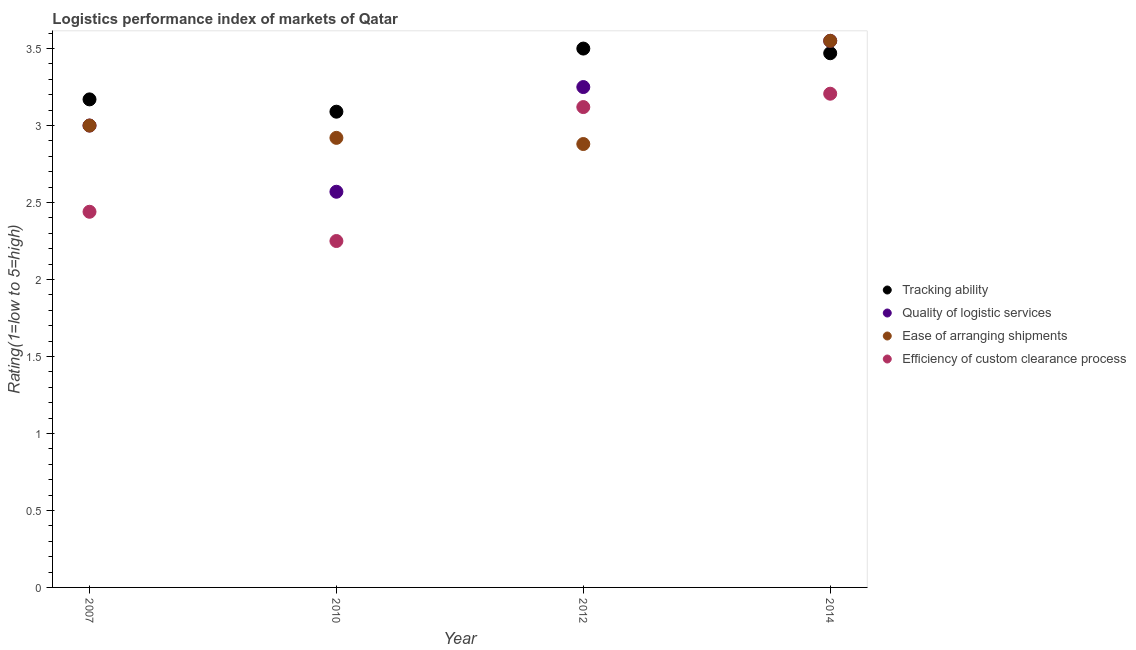How many different coloured dotlines are there?
Ensure brevity in your answer.  4. What is the lpi rating of quality of logistic services in 2014?
Your answer should be very brief. 3.55. Across all years, what is the maximum lpi rating of tracking ability?
Your answer should be very brief. 3.5. Across all years, what is the minimum lpi rating of quality of logistic services?
Your answer should be very brief. 2.57. In which year was the lpi rating of efficiency of custom clearance process maximum?
Keep it short and to the point. 2014. In which year was the lpi rating of quality of logistic services minimum?
Give a very brief answer. 2010. What is the total lpi rating of efficiency of custom clearance process in the graph?
Your answer should be compact. 11.02. What is the difference between the lpi rating of tracking ability in 2010 and that in 2014?
Offer a very short reply. -0.38. What is the difference between the lpi rating of ease of arranging shipments in 2007 and the lpi rating of quality of logistic services in 2012?
Make the answer very short. -0.25. What is the average lpi rating of efficiency of custom clearance process per year?
Give a very brief answer. 2.75. In the year 2010, what is the difference between the lpi rating of tracking ability and lpi rating of efficiency of custom clearance process?
Ensure brevity in your answer.  0.84. What is the ratio of the lpi rating of quality of logistic services in 2012 to that in 2014?
Keep it short and to the point. 0.92. Is the lpi rating of ease of arranging shipments in 2010 less than that in 2014?
Ensure brevity in your answer.  Yes. Is the difference between the lpi rating of tracking ability in 2010 and 2014 greater than the difference between the lpi rating of ease of arranging shipments in 2010 and 2014?
Your answer should be compact. Yes. What is the difference between the highest and the second highest lpi rating of efficiency of custom clearance process?
Provide a succinct answer. 0.09. What is the difference between the highest and the lowest lpi rating of efficiency of custom clearance process?
Your answer should be very brief. 0.96. Is the sum of the lpi rating of quality of logistic services in 2007 and 2010 greater than the maximum lpi rating of ease of arranging shipments across all years?
Your response must be concise. Yes. Is it the case that in every year, the sum of the lpi rating of quality of logistic services and lpi rating of ease of arranging shipments is greater than the sum of lpi rating of efficiency of custom clearance process and lpi rating of tracking ability?
Your response must be concise. No. Does the lpi rating of efficiency of custom clearance process monotonically increase over the years?
Ensure brevity in your answer.  No. How many dotlines are there?
Offer a terse response. 4. How many years are there in the graph?
Give a very brief answer. 4. What is the difference between two consecutive major ticks on the Y-axis?
Give a very brief answer. 0.5. Does the graph contain any zero values?
Ensure brevity in your answer.  No. Does the graph contain grids?
Your answer should be very brief. No. How many legend labels are there?
Make the answer very short. 4. How are the legend labels stacked?
Your answer should be compact. Vertical. What is the title of the graph?
Keep it short and to the point. Logistics performance index of markets of Qatar. What is the label or title of the Y-axis?
Your answer should be compact. Rating(1=low to 5=high). What is the Rating(1=low to 5=high) in Tracking ability in 2007?
Provide a short and direct response. 3.17. What is the Rating(1=low to 5=high) in Quality of logistic services in 2007?
Your answer should be very brief. 3. What is the Rating(1=low to 5=high) in Ease of arranging shipments in 2007?
Your response must be concise. 3. What is the Rating(1=low to 5=high) of Efficiency of custom clearance process in 2007?
Give a very brief answer. 2.44. What is the Rating(1=low to 5=high) of Tracking ability in 2010?
Keep it short and to the point. 3.09. What is the Rating(1=low to 5=high) of Quality of logistic services in 2010?
Provide a succinct answer. 2.57. What is the Rating(1=low to 5=high) of Ease of arranging shipments in 2010?
Make the answer very short. 2.92. What is the Rating(1=low to 5=high) of Efficiency of custom clearance process in 2010?
Keep it short and to the point. 2.25. What is the Rating(1=low to 5=high) of Ease of arranging shipments in 2012?
Your answer should be compact. 2.88. What is the Rating(1=low to 5=high) in Efficiency of custom clearance process in 2012?
Make the answer very short. 3.12. What is the Rating(1=low to 5=high) of Tracking ability in 2014?
Give a very brief answer. 3.47. What is the Rating(1=low to 5=high) in Quality of logistic services in 2014?
Your response must be concise. 3.55. What is the Rating(1=low to 5=high) of Ease of arranging shipments in 2014?
Your answer should be very brief. 3.55. What is the Rating(1=low to 5=high) of Efficiency of custom clearance process in 2014?
Your answer should be compact. 3.21. Across all years, what is the maximum Rating(1=low to 5=high) of Quality of logistic services?
Make the answer very short. 3.55. Across all years, what is the maximum Rating(1=low to 5=high) of Ease of arranging shipments?
Your answer should be very brief. 3.55. Across all years, what is the maximum Rating(1=low to 5=high) of Efficiency of custom clearance process?
Provide a short and direct response. 3.21. Across all years, what is the minimum Rating(1=low to 5=high) in Tracking ability?
Give a very brief answer. 3.09. Across all years, what is the minimum Rating(1=low to 5=high) in Quality of logistic services?
Your answer should be compact. 2.57. Across all years, what is the minimum Rating(1=low to 5=high) of Ease of arranging shipments?
Offer a very short reply. 2.88. Across all years, what is the minimum Rating(1=low to 5=high) in Efficiency of custom clearance process?
Your answer should be compact. 2.25. What is the total Rating(1=low to 5=high) of Tracking ability in the graph?
Provide a short and direct response. 13.23. What is the total Rating(1=low to 5=high) in Quality of logistic services in the graph?
Your response must be concise. 12.37. What is the total Rating(1=low to 5=high) in Ease of arranging shipments in the graph?
Provide a short and direct response. 12.35. What is the total Rating(1=low to 5=high) of Efficiency of custom clearance process in the graph?
Your response must be concise. 11.02. What is the difference between the Rating(1=low to 5=high) of Quality of logistic services in 2007 and that in 2010?
Your answer should be very brief. 0.43. What is the difference between the Rating(1=low to 5=high) of Efficiency of custom clearance process in 2007 and that in 2010?
Your response must be concise. 0.19. What is the difference between the Rating(1=low to 5=high) of Tracking ability in 2007 and that in 2012?
Ensure brevity in your answer.  -0.33. What is the difference between the Rating(1=low to 5=high) of Quality of logistic services in 2007 and that in 2012?
Provide a succinct answer. -0.25. What is the difference between the Rating(1=low to 5=high) in Ease of arranging shipments in 2007 and that in 2012?
Keep it short and to the point. 0.12. What is the difference between the Rating(1=low to 5=high) of Efficiency of custom clearance process in 2007 and that in 2012?
Provide a succinct answer. -0.68. What is the difference between the Rating(1=low to 5=high) in Tracking ability in 2007 and that in 2014?
Provide a short and direct response. -0.3. What is the difference between the Rating(1=low to 5=high) in Quality of logistic services in 2007 and that in 2014?
Provide a succinct answer. -0.55. What is the difference between the Rating(1=low to 5=high) in Ease of arranging shipments in 2007 and that in 2014?
Ensure brevity in your answer.  -0.55. What is the difference between the Rating(1=low to 5=high) of Efficiency of custom clearance process in 2007 and that in 2014?
Your response must be concise. -0.77. What is the difference between the Rating(1=low to 5=high) in Tracking ability in 2010 and that in 2012?
Provide a succinct answer. -0.41. What is the difference between the Rating(1=low to 5=high) in Quality of logistic services in 2010 and that in 2012?
Your answer should be compact. -0.68. What is the difference between the Rating(1=low to 5=high) in Efficiency of custom clearance process in 2010 and that in 2012?
Your answer should be compact. -0.87. What is the difference between the Rating(1=low to 5=high) in Tracking ability in 2010 and that in 2014?
Keep it short and to the point. -0.38. What is the difference between the Rating(1=low to 5=high) of Quality of logistic services in 2010 and that in 2014?
Provide a succinct answer. -0.98. What is the difference between the Rating(1=low to 5=high) in Ease of arranging shipments in 2010 and that in 2014?
Provide a short and direct response. -0.63. What is the difference between the Rating(1=low to 5=high) in Efficiency of custom clearance process in 2010 and that in 2014?
Provide a succinct answer. -0.96. What is the difference between the Rating(1=low to 5=high) of Tracking ability in 2012 and that in 2014?
Your answer should be compact. 0.03. What is the difference between the Rating(1=low to 5=high) of Quality of logistic services in 2012 and that in 2014?
Offer a terse response. -0.3. What is the difference between the Rating(1=low to 5=high) in Ease of arranging shipments in 2012 and that in 2014?
Ensure brevity in your answer.  -0.67. What is the difference between the Rating(1=low to 5=high) of Efficiency of custom clearance process in 2012 and that in 2014?
Your answer should be very brief. -0.09. What is the difference between the Rating(1=low to 5=high) in Tracking ability in 2007 and the Rating(1=low to 5=high) in Ease of arranging shipments in 2010?
Offer a very short reply. 0.25. What is the difference between the Rating(1=low to 5=high) in Quality of logistic services in 2007 and the Rating(1=low to 5=high) in Ease of arranging shipments in 2010?
Your answer should be very brief. 0.08. What is the difference between the Rating(1=low to 5=high) of Quality of logistic services in 2007 and the Rating(1=low to 5=high) of Efficiency of custom clearance process in 2010?
Ensure brevity in your answer.  0.75. What is the difference between the Rating(1=low to 5=high) of Tracking ability in 2007 and the Rating(1=low to 5=high) of Quality of logistic services in 2012?
Your answer should be very brief. -0.08. What is the difference between the Rating(1=low to 5=high) in Tracking ability in 2007 and the Rating(1=low to 5=high) in Ease of arranging shipments in 2012?
Provide a short and direct response. 0.29. What is the difference between the Rating(1=low to 5=high) in Tracking ability in 2007 and the Rating(1=low to 5=high) in Efficiency of custom clearance process in 2012?
Offer a terse response. 0.05. What is the difference between the Rating(1=low to 5=high) in Quality of logistic services in 2007 and the Rating(1=low to 5=high) in Ease of arranging shipments in 2012?
Keep it short and to the point. 0.12. What is the difference between the Rating(1=low to 5=high) in Quality of logistic services in 2007 and the Rating(1=low to 5=high) in Efficiency of custom clearance process in 2012?
Keep it short and to the point. -0.12. What is the difference between the Rating(1=low to 5=high) in Ease of arranging shipments in 2007 and the Rating(1=low to 5=high) in Efficiency of custom clearance process in 2012?
Keep it short and to the point. -0.12. What is the difference between the Rating(1=low to 5=high) in Tracking ability in 2007 and the Rating(1=low to 5=high) in Quality of logistic services in 2014?
Keep it short and to the point. -0.38. What is the difference between the Rating(1=low to 5=high) in Tracking ability in 2007 and the Rating(1=low to 5=high) in Ease of arranging shipments in 2014?
Your response must be concise. -0.38. What is the difference between the Rating(1=low to 5=high) in Tracking ability in 2007 and the Rating(1=low to 5=high) in Efficiency of custom clearance process in 2014?
Offer a terse response. -0.04. What is the difference between the Rating(1=low to 5=high) of Quality of logistic services in 2007 and the Rating(1=low to 5=high) of Ease of arranging shipments in 2014?
Your answer should be very brief. -0.55. What is the difference between the Rating(1=low to 5=high) in Quality of logistic services in 2007 and the Rating(1=low to 5=high) in Efficiency of custom clearance process in 2014?
Provide a short and direct response. -0.21. What is the difference between the Rating(1=low to 5=high) of Ease of arranging shipments in 2007 and the Rating(1=low to 5=high) of Efficiency of custom clearance process in 2014?
Offer a terse response. -0.21. What is the difference between the Rating(1=low to 5=high) of Tracking ability in 2010 and the Rating(1=low to 5=high) of Quality of logistic services in 2012?
Offer a terse response. -0.16. What is the difference between the Rating(1=low to 5=high) in Tracking ability in 2010 and the Rating(1=low to 5=high) in Ease of arranging shipments in 2012?
Ensure brevity in your answer.  0.21. What is the difference between the Rating(1=low to 5=high) in Tracking ability in 2010 and the Rating(1=low to 5=high) in Efficiency of custom clearance process in 2012?
Your answer should be very brief. -0.03. What is the difference between the Rating(1=low to 5=high) in Quality of logistic services in 2010 and the Rating(1=low to 5=high) in Ease of arranging shipments in 2012?
Make the answer very short. -0.31. What is the difference between the Rating(1=low to 5=high) of Quality of logistic services in 2010 and the Rating(1=low to 5=high) of Efficiency of custom clearance process in 2012?
Provide a short and direct response. -0.55. What is the difference between the Rating(1=low to 5=high) in Ease of arranging shipments in 2010 and the Rating(1=low to 5=high) in Efficiency of custom clearance process in 2012?
Give a very brief answer. -0.2. What is the difference between the Rating(1=low to 5=high) of Tracking ability in 2010 and the Rating(1=low to 5=high) of Quality of logistic services in 2014?
Keep it short and to the point. -0.46. What is the difference between the Rating(1=low to 5=high) in Tracking ability in 2010 and the Rating(1=low to 5=high) in Ease of arranging shipments in 2014?
Offer a terse response. -0.46. What is the difference between the Rating(1=low to 5=high) of Tracking ability in 2010 and the Rating(1=low to 5=high) of Efficiency of custom clearance process in 2014?
Give a very brief answer. -0.12. What is the difference between the Rating(1=low to 5=high) of Quality of logistic services in 2010 and the Rating(1=low to 5=high) of Ease of arranging shipments in 2014?
Keep it short and to the point. -0.98. What is the difference between the Rating(1=low to 5=high) in Quality of logistic services in 2010 and the Rating(1=low to 5=high) in Efficiency of custom clearance process in 2014?
Ensure brevity in your answer.  -0.64. What is the difference between the Rating(1=low to 5=high) in Ease of arranging shipments in 2010 and the Rating(1=low to 5=high) in Efficiency of custom clearance process in 2014?
Ensure brevity in your answer.  -0.29. What is the difference between the Rating(1=low to 5=high) of Tracking ability in 2012 and the Rating(1=low to 5=high) of Quality of logistic services in 2014?
Your response must be concise. -0.05. What is the difference between the Rating(1=low to 5=high) in Tracking ability in 2012 and the Rating(1=low to 5=high) in Ease of arranging shipments in 2014?
Provide a short and direct response. -0.05. What is the difference between the Rating(1=low to 5=high) in Tracking ability in 2012 and the Rating(1=low to 5=high) in Efficiency of custom clearance process in 2014?
Your answer should be compact. 0.29. What is the difference between the Rating(1=low to 5=high) in Quality of logistic services in 2012 and the Rating(1=low to 5=high) in Ease of arranging shipments in 2014?
Make the answer very short. -0.3. What is the difference between the Rating(1=low to 5=high) in Quality of logistic services in 2012 and the Rating(1=low to 5=high) in Efficiency of custom clearance process in 2014?
Give a very brief answer. 0.04. What is the difference between the Rating(1=low to 5=high) of Ease of arranging shipments in 2012 and the Rating(1=low to 5=high) of Efficiency of custom clearance process in 2014?
Offer a very short reply. -0.33. What is the average Rating(1=low to 5=high) in Tracking ability per year?
Your answer should be very brief. 3.31. What is the average Rating(1=low to 5=high) of Quality of logistic services per year?
Provide a succinct answer. 3.09. What is the average Rating(1=low to 5=high) in Ease of arranging shipments per year?
Your response must be concise. 3.09. What is the average Rating(1=low to 5=high) in Efficiency of custom clearance process per year?
Ensure brevity in your answer.  2.75. In the year 2007, what is the difference between the Rating(1=low to 5=high) in Tracking ability and Rating(1=low to 5=high) in Quality of logistic services?
Offer a very short reply. 0.17. In the year 2007, what is the difference between the Rating(1=low to 5=high) in Tracking ability and Rating(1=low to 5=high) in Ease of arranging shipments?
Give a very brief answer. 0.17. In the year 2007, what is the difference between the Rating(1=low to 5=high) in Tracking ability and Rating(1=low to 5=high) in Efficiency of custom clearance process?
Keep it short and to the point. 0.73. In the year 2007, what is the difference between the Rating(1=low to 5=high) in Quality of logistic services and Rating(1=low to 5=high) in Efficiency of custom clearance process?
Give a very brief answer. 0.56. In the year 2007, what is the difference between the Rating(1=low to 5=high) in Ease of arranging shipments and Rating(1=low to 5=high) in Efficiency of custom clearance process?
Give a very brief answer. 0.56. In the year 2010, what is the difference between the Rating(1=low to 5=high) of Tracking ability and Rating(1=low to 5=high) of Quality of logistic services?
Ensure brevity in your answer.  0.52. In the year 2010, what is the difference between the Rating(1=low to 5=high) of Tracking ability and Rating(1=low to 5=high) of Ease of arranging shipments?
Your answer should be compact. 0.17. In the year 2010, what is the difference between the Rating(1=low to 5=high) of Tracking ability and Rating(1=low to 5=high) of Efficiency of custom clearance process?
Ensure brevity in your answer.  0.84. In the year 2010, what is the difference between the Rating(1=low to 5=high) of Quality of logistic services and Rating(1=low to 5=high) of Ease of arranging shipments?
Your response must be concise. -0.35. In the year 2010, what is the difference between the Rating(1=low to 5=high) in Quality of logistic services and Rating(1=low to 5=high) in Efficiency of custom clearance process?
Make the answer very short. 0.32. In the year 2010, what is the difference between the Rating(1=low to 5=high) in Ease of arranging shipments and Rating(1=low to 5=high) in Efficiency of custom clearance process?
Your response must be concise. 0.67. In the year 2012, what is the difference between the Rating(1=low to 5=high) of Tracking ability and Rating(1=low to 5=high) of Quality of logistic services?
Keep it short and to the point. 0.25. In the year 2012, what is the difference between the Rating(1=low to 5=high) of Tracking ability and Rating(1=low to 5=high) of Ease of arranging shipments?
Your response must be concise. 0.62. In the year 2012, what is the difference between the Rating(1=low to 5=high) in Tracking ability and Rating(1=low to 5=high) in Efficiency of custom clearance process?
Ensure brevity in your answer.  0.38. In the year 2012, what is the difference between the Rating(1=low to 5=high) in Quality of logistic services and Rating(1=low to 5=high) in Ease of arranging shipments?
Give a very brief answer. 0.37. In the year 2012, what is the difference between the Rating(1=low to 5=high) in Quality of logistic services and Rating(1=low to 5=high) in Efficiency of custom clearance process?
Give a very brief answer. 0.13. In the year 2012, what is the difference between the Rating(1=low to 5=high) in Ease of arranging shipments and Rating(1=low to 5=high) in Efficiency of custom clearance process?
Your answer should be very brief. -0.24. In the year 2014, what is the difference between the Rating(1=low to 5=high) of Tracking ability and Rating(1=low to 5=high) of Quality of logistic services?
Your answer should be compact. -0.08. In the year 2014, what is the difference between the Rating(1=low to 5=high) in Tracking ability and Rating(1=low to 5=high) in Ease of arranging shipments?
Provide a short and direct response. -0.08. In the year 2014, what is the difference between the Rating(1=low to 5=high) in Tracking ability and Rating(1=low to 5=high) in Efficiency of custom clearance process?
Provide a short and direct response. 0.26. In the year 2014, what is the difference between the Rating(1=low to 5=high) of Quality of logistic services and Rating(1=low to 5=high) of Efficiency of custom clearance process?
Provide a succinct answer. 0.34. In the year 2014, what is the difference between the Rating(1=low to 5=high) of Ease of arranging shipments and Rating(1=low to 5=high) of Efficiency of custom clearance process?
Your answer should be very brief. 0.34. What is the ratio of the Rating(1=low to 5=high) of Tracking ability in 2007 to that in 2010?
Your answer should be very brief. 1.03. What is the ratio of the Rating(1=low to 5=high) of Quality of logistic services in 2007 to that in 2010?
Give a very brief answer. 1.17. What is the ratio of the Rating(1=low to 5=high) in Ease of arranging shipments in 2007 to that in 2010?
Your answer should be very brief. 1.03. What is the ratio of the Rating(1=low to 5=high) of Efficiency of custom clearance process in 2007 to that in 2010?
Provide a short and direct response. 1.08. What is the ratio of the Rating(1=low to 5=high) in Tracking ability in 2007 to that in 2012?
Ensure brevity in your answer.  0.91. What is the ratio of the Rating(1=low to 5=high) of Quality of logistic services in 2007 to that in 2012?
Give a very brief answer. 0.92. What is the ratio of the Rating(1=low to 5=high) in Ease of arranging shipments in 2007 to that in 2012?
Ensure brevity in your answer.  1.04. What is the ratio of the Rating(1=low to 5=high) in Efficiency of custom clearance process in 2007 to that in 2012?
Your answer should be very brief. 0.78. What is the ratio of the Rating(1=low to 5=high) in Tracking ability in 2007 to that in 2014?
Make the answer very short. 0.91. What is the ratio of the Rating(1=low to 5=high) in Quality of logistic services in 2007 to that in 2014?
Your response must be concise. 0.84. What is the ratio of the Rating(1=low to 5=high) of Ease of arranging shipments in 2007 to that in 2014?
Provide a succinct answer. 0.84. What is the ratio of the Rating(1=low to 5=high) in Efficiency of custom clearance process in 2007 to that in 2014?
Offer a very short reply. 0.76. What is the ratio of the Rating(1=low to 5=high) of Tracking ability in 2010 to that in 2012?
Give a very brief answer. 0.88. What is the ratio of the Rating(1=low to 5=high) in Quality of logistic services in 2010 to that in 2012?
Your answer should be compact. 0.79. What is the ratio of the Rating(1=low to 5=high) in Ease of arranging shipments in 2010 to that in 2012?
Your answer should be very brief. 1.01. What is the ratio of the Rating(1=low to 5=high) of Efficiency of custom clearance process in 2010 to that in 2012?
Ensure brevity in your answer.  0.72. What is the ratio of the Rating(1=low to 5=high) in Tracking ability in 2010 to that in 2014?
Give a very brief answer. 0.89. What is the ratio of the Rating(1=low to 5=high) in Quality of logistic services in 2010 to that in 2014?
Offer a very short reply. 0.72. What is the ratio of the Rating(1=low to 5=high) in Ease of arranging shipments in 2010 to that in 2014?
Your response must be concise. 0.82. What is the ratio of the Rating(1=low to 5=high) of Efficiency of custom clearance process in 2010 to that in 2014?
Give a very brief answer. 0.7. What is the ratio of the Rating(1=low to 5=high) of Tracking ability in 2012 to that in 2014?
Provide a succinct answer. 1.01. What is the ratio of the Rating(1=low to 5=high) of Quality of logistic services in 2012 to that in 2014?
Offer a very short reply. 0.92. What is the ratio of the Rating(1=low to 5=high) of Ease of arranging shipments in 2012 to that in 2014?
Make the answer very short. 0.81. What is the ratio of the Rating(1=low to 5=high) in Efficiency of custom clearance process in 2012 to that in 2014?
Make the answer very short. 0.97. What is the difference between the highest and the second highest Rating(1=low to 5=high) in Tracking ability?
Keep it short and to the point. 0.03. What is the difference between the highest and the second highest Rating(1=low to 5=high) of Quality of logistic services?
Ensure brevity in your answer.  0.3. What is the difference between the highest and the second highest Rating(1=low to 5=high) in Ease of arranging shipments?
Provide a short and direct response. 0.55. What is the difference between the highest and the second highest Rating(1=low to 5=high) in Efficiency of custom clearance process?
Your answer should be compact. 0.09. What is the difference between the highest and the lowest Rating(1=low to 5=high) of Tracking ability?
Your answer should be very brief. 0.41. What is the difference between the highest and the lowest Rating(1=low to 5=high) of Quality of logistic services?
Your answer should be very brief. 0.98. What is the difference between the highest and the lowest Rating(1=low to 5=high) in Ease of arranging shipments?
Provide a short and direct response. 0.67. What is the difference between the highest and the lowest Rating(1=low to 5=high) of Efficiency of custom clearance process?
Your answer should be very brief. 0.96. 